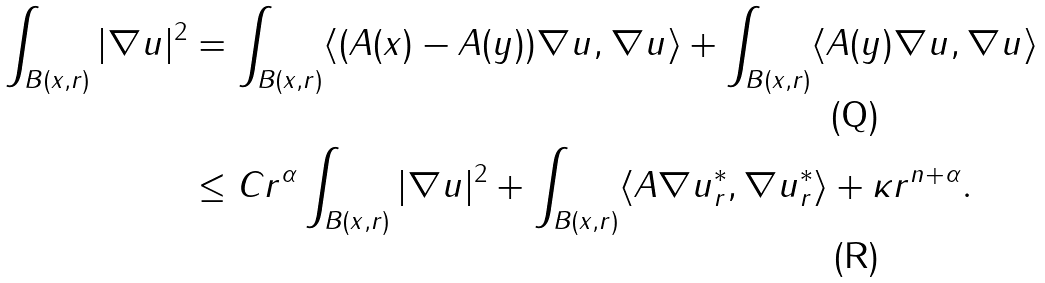<formula> <loc_0><loc_0><loc_500><loc_500>\int _ { B ( x , r ) } | \nabla u | ^ { 2 } & = \int _ { B ( x , r ) } \langle ( A ( x ) - A ( y ) ) \nabla u , \nabla u \rangle + \int _ { B ( x , r ) } \langle A ( y ) \nabla u , \nabla u \rangle \\ & \leq C r ^ { \alpha } \int _ { B ( x , r ) } | \nabla u | ^ { 2 } + \int _ { B ( x , r ) } \langle A \nabla u _ { r } ^ { * } , \nabla u _ { r } ^ { * } \rangle + \kappa r ^ { n + \alpha } .</formula> 